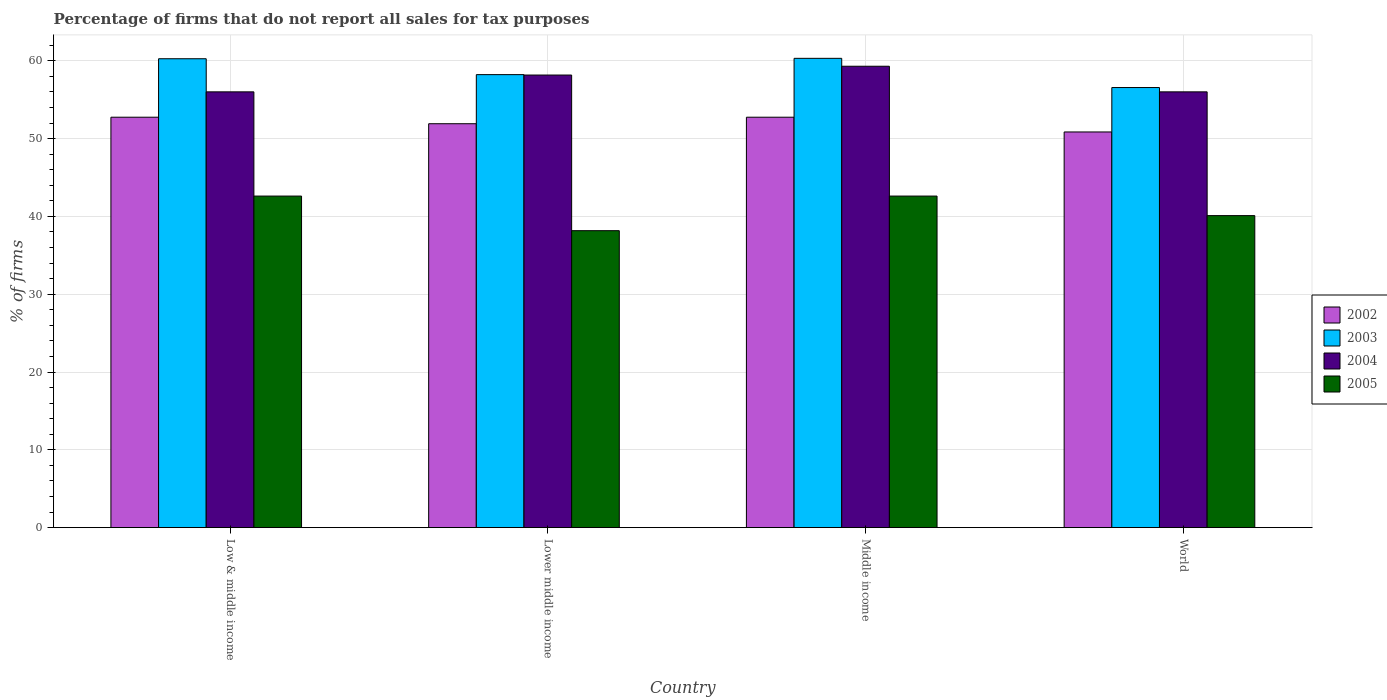How many groups of bars are there?
Provide a succinct answer. 4. Are the number of bars per tick equal to the number of legend labels?
Make the answer very short. Yes. Are the number of bars on each tick of the X-axis equal?
Your answer should be very brief. Yes. How many bars are there on the 2nd tick from the left?
Offer a terse response. 4. How many bars are there on the 4th tick from the right?
Your answer should be very brief. 4. What is the label of the 3rd group of bars from the left?
Your response must be concise. Middle income. What is the percentage of firms that do not report all sales for tax purposes in 2002 in World?
Ensure brevity in your answer.  50.85. Across all countries, what is the maximum percentage of firms that do not report all sales for tax purposes in 2004?
Provide a succinct answer. 59.3. Across all countries, what is the minimum percentage of firms that do not report all sales for tax purposes in 2004?
Offer a very short reply. 56.01. In which country was the percentage of firms that do not report all sales for tax purposes in 2004 minimum?
Your answer should be compact. Low & middle income. What is the total percentage of firms that do not report all sales for tax purposes in 2005 in the graph?
Ensure brevity in your answer.  163.48. What is the difference between the percentage of firms that do not report all sales for tax purposes in 2005 in Low & middle income and that in Lower middle income?
Your response must be concise. 4.45. What is the difference between the percentage of firms that do not report all sales for tax purposes in 2004 in Lower middle income and the percentage of firms that do not report all sales for tax purposes in 2005 in Middle income?
Make the answer very short. 15.55. What is the average percentage of firms that do not report all sales for tax purposes in 2005 per country?
Your response must be concise. 40.87. What is the difference between the percentage of firms that do not report all sales for tax purposes of/in 2002 and percentage of firms that do not report all sales for tax purposes of/in 2005 in World?
Provide a succinct answer. 10.75. What is the ratio of the percentage of firms that do not report all sales for tax purposes in 2002 in Lower middle income to that in Middle income?
Make the answer very short. 0.98. Is the percentage of firms that do not report all sales for tax purposes in 2003 in Low & middle income less than that in Lower middle income?
Offer a terse response. No. Is the difference between the percentage of firms that do not report all sales for tax purposes in 2002 in Lower middle income and Middle income greater than the difference between the percentage of firms that do not report all sales for tax purposes in 2005 in Lower middle income and Middle income?
Ensure brevity in your answer.  Yes. What is the difference between the highest and the second highest percentage of firms that do not report all sales for tax purposes in 2002?
Provide a short and direct response. -0.84. What is the difference between the highest and the lowest percentage of firms that do not report all sales for tax purposes in 2005?
Your answer should be very brief. 4.45. What does the 4th bar from the right in Low & middle income represents?
Make the answer very short. 2002. Is it the case that in every country, the sum of the percentage of firms that do not report all sales for tax purposes in 2002 and percentage of firms that do not report all sales for tax purposes in 2005 is greater than the percentage of firms that do not report all sales for tax purposes in 2004?
Your response must be concise. Yes. How many bars are there?
Give a very brief answer. 16. Are all the bars in the graph horizontal?
Make the answer very short. No. Are the values on the major ticks of Y-axis written in scientific E-notation?
Provide a short and direct response. No. Does the graph contain any zero values?
Offer a terse response. No. Does the graph contain grids?
Make the answer very short. Yes. Where does the legend appear in the graph?
Provide a short and direct response. Center right. How many legend labels are there?
Your answer should be very brief. 4. What is the title of the graph?
Make the answer very short. Percentage of firms that do not report all sales for tax purposes. Does "2005" appear as one of the legend labels in the graph?
Provide a short and direct response. Yes. What is the label or title of the X-axis?
Provide a short and direct response. Country. What is the label or title of the Y-axis?
Give a very brief answer. % of firms. What is the % of firms in 2002 in Low & middle income?
Make the answer very short. 52.75. What is the % of firms of 2003 in Low & middle income?
Keep it short and to the point. 60.26. What is the % of firms in 2004 in Low & middle income?
Give a very brief answer. 56.01. What is the % of firms of 2005 in Low & middle income?
Provide a succinct answer. 42.61. What is the % of firms in 2002 in Lower middle income?
Your answer should be very brief. 51.91. What is the % of firms in 2003 in Lower middle income?
Keep it short and to the point. 58.22. What is the % of firms of 2004 in Lower middle income?
Your answer should be very brief. 58.16. What is the % of firms in 2005 in Lower middle income?
Keep it short and to the point. 38.16. What is the % of firms of 2002 in Middle income?
Provide a short and direct response. 52.75. What is the % of firms in 2003 in Middle income?
Provide a succinct answer. 60.31. What is the % of firms of 2004 in Middle income?
Offer a terse response. 59.3. What is the % of firms in 2005 in Middle income?
Provide a succinct answer. 42.61. What is the % of firms in 2002 in World?
Give a very brief answer. 50.85. What is the % of firms of 2003 in World?
Ensure brevity in your answer.  56.56. What is the % of firms of 2004 in World?
Your answer should be compact. 56.01. What is the % of firms in 2005 in World?
Give a very brief answer. 40.1. Across all countries, what is the maximum % of firms in 2002?
Your answer should be very brief. 52.75. Across all countries, what is the maximum % of firms of 2003?
Give a very brief answer. 60.31. Across all countries, what is the maximum % of firms of 2004?
Keep it short and to the point. 59.3. Across all countries, what is the maximum % of firms of 2005?
Your answer should be compact. 42.61. Across all countries, what is the minimum % of firms of 2002?
Offer a very short reply. 50.85. Across all countries, what is the minimum % of firms of 2003?
Provide a succinct answer. 56.56. Across all countries, what is the minimum % of firms of 2004?
Offer a very short reply. 56.01. Across all countries, what is the minimum % of firms of 2005?
Offer a terse response. 38.16. What is the total % of firms of 2002 in the graph?
Offer a very short reply. 208.25. What is the total % of firms of 2003 in the graph?
Make the answer very short. 235.35. What is the total % of firms in 2004 in the graph?
Provide a succinct answer. 229.47. What is the total % of firms in 2005 in the graph?
Your response must be concise. 163.48. What is the difference between the % of firms in 2002 in Low & middle income and that in Lower middle income?
Offer a terse response. 0.84. What is the difference between the % of firms in 2003 in Low & middle income and that in Lower middle income?
Make the answer very short. 2.04. What is the difference between the % of firms of 2004 in Low & middle income and that in Lower middle income?
Give a very brief answer. -2.16. What is the difference between the % of firms in 2005 in Low & middle income and that in Lower middle income?
Your answer should be very brief. 4.45. What is the difference between the % of firms in 2003 in Low & middle income and that in Middle income?
Your answer should be compact. -0.05. What is the difference between the % of firms of 2004 in Low & middle income and that in Middle income?
Your response must be concise. -3.29. What is the difference between the % of firms of 2002 in Low & middle income and that in World?
Keep it short and to the point. 1.89. What is the difference between the % of firms in 2005 in Low & middle income and that in World?
Your answer should be very brief. 2.51. What is the difference between the % of firms of 2002 in Lower middle income and that in Middle income?
Provide a succinct answer. -0.84. What is the difference between the % of firms of 2003 in Lower middle income and that in Middle income?
Give a very brief answer. -2.09. What is the difference between the % of firms of 2004 in Lower middle income and that in Middle income?
Offer a terse response. -1.13. What is the difference between the % of firms of 2005 in Lower middle income and that in Middle income?
Offer a terse response. -4.45. What is the difference between the % of firms in 2002 in Lower middle income and that in World?
Make the answer very short. 1.06. What is the difference between the % of firms of 2003 in Lower middle income and that in World?
Make the answer very short. 1.66. What is the difference between the % of firms in 2004 in Lower middle income and that in World?
Your answer should be compact. 2.16. What is the difference between the % of firms in 2005 in Lower middle income and that in World?
Provide a short and direct response. -1.94. What is the difference between the % of firms in 2002 in Middle income and that in World?
Make the answer very short. 1.89. What is the difference between the % of firms in 2003 in Middle income and that in World?
Keep it short and to the point. 3.75. What is the difference between the % of firms of 2004 in Middle income and that in World?
Offer a very short reply. 3.29. What is the difference between the % of firms in 2005 in Middle income and that in World?
Keep it short and to the point. 2.51. What is the difference between the % of firms in 2002 in Low & middle income and the % of firms in 2003 in Lower middle income?
Keep it short and to the point. -5.47. What is the difference between the % of firms in 2002 in Low & middle income and the % of firms in 2004 in Lower middle income?
Your answer should be very brief. -5.42. What is the difference between the % of firms of 2002 in Low & middle income and the % of firms of 2005 in Lower middle income?
Offer a terse response. 14.58. What is the difference between the % of firms in 2003 in Low & middle income and the % of firms in 2004 in Lower middle income?
Ensure brevity in your answer.  2.1. What is the difference between the % of firms of 2003 in Low & middle income and the % of firms of 2005 in Lower middle income?
Ensure brevity in your answer.  22.1. What is the difference between the % of firms in 2004 in Low & middle income and the % of firms in 2005 in Lower middle income?
Ensure brevity in your answer.  17.84. What is the difference between the % of firms in 2002 in Low & middle income and the % of firms in 2003 in Middle income?
Make the answer very short. -7.57. What is the difference between the % of firms of 2002 in Low & middle income and the % of firms of 2004 in Middle income?
Provide a short and direct response. -6.55. What is the difference between the % of firms in 2002 in Low & middle income and the % of firms in 2005 in Middle income?
Your response must be concise. 10.13. What is the difference between the % of firms in 2003 in Low & middle income and the % of firms in 2004 in Middle income?
Offer a terse response. 0.96. What is the difference between the % of firms of 2003 in Low & middle income and the % of firms of 2005 in Middle income?
Ensure brevity in your answer.  17.65. What is the difference between the % of firms in 2004 in Low & middle income and the % of firms in 2005 in Middle income?
Offer a terse response. 13.39. What is the difference between the % of firms in 2002 in Low & middle income and the % of firms in 2003 in World?
Your answer should be very brief. -3.81. What is the difference between the % of firms in 2002 in Low & middle income and the % of firms in 2004 in World?
Your answer should be compact. -3.26. What is the difference between the % of firms in 2002 in Low & middle income and the % of firms in 2005 in World?
Offer a terse response. 12.65. What is the difference between the % of firms in 2003 in Low & middle income and the % of firms in 2004 in World?
Your response must be concise. 4.25. What is the difference between the % of firms in 2003 in Low & middle income and the % of firms in 2005 in World?
Your answer should be compact. 20.16. What is the difference between the % of firms of 2004 in Low & middle income and the % of firms of 2005 in World?
Keep it short and to the point. 15.91. What is the difference between the % of firms of 2002 in Lower middle income and the % of firms of 2003 in Middle income?
Offer a terse response. -8.4. What is the difference between the % of firms in 2002 in Lower middle income and the % of firms in 2004 in Middle income?
Provide a short and direct response. -7.39. What is the difference between the % of firms in 2002 in Lower middle income and the % of firms in 2005 in Middle income?
Make the answer very short. 9.3. What is the difference between the % of firms in 2003 in Lower middle income and the % of firms in 2004 in Middle income?
Give a very brief answer. -1.08. What is the difference between the % of firms in 2003 in Lower middle income and the % of firms in 2005 in Middle income?
Provide a succinct answer. 15.61. What is the difference between the % of firms in 2004 in Lower middle income and the % of firms in 2005 in Middle income?
Your answer should be very brief. 15.55. What is the difference between the % of firms of 2002 in Lower middle income and the % of firms of 2003 in World?
Offer a terse response. -4.65. What is the difference between the % of firms in 2002 in Lower middle income and the % of firms in 2004 in World?
Your answer should be compact. -4.1. What is the difference between the % of firms in 2002 in Lower middle income and the % of firms in 2005 in World?
Your answer should be compact. 11.81. What is the difference between the % of firms of 2003 in Lower middle income and the % of firms of 2004 in World?
Offer a very short reply. 2.21. What is the difference between the % of firms of 2003 in Lower middle income and the % of firms of 2005 in World?
Keep it short and to the point. 18.12. What is the difference between the % of firms of 2004 in Lower middle income and the % of firms of 2005 in World?
Keep it short and to the point. 18.07. What is the difference between the % of firms in 2002 in Middle income and the % of firms in 2003 in World?
Your answer should be very brief. -3.81. What is the difference between the % of firms of 2002 in Middle income and the % of firms of 2004 in World?
Offer a very short reply. -3.26. What is the difference between the % of firms in 2002 in Middle income and the % of firms in 2005 in World?
Make the answer very short. 12.65. What is the difference between the % of firms in 2003 in Middle income and the % of firms in 2004 in World?
Offer a terse response. 4.31. What is the difference between the % of firms of 2003 in Middle income and the % of firms of 2005 in World?
Provide a short and direct response. 20.21. What is the difference between the % of firms of 2004 in Middle income and the % of firms of 2005 in World?
Ensure brevity in your answer.  19.2. What is the average % of firms in 2002 per country?
Provide a short and direct response. 52.06. What is the average % of firms in 2003 per country?
Provide a succinct answer. 58.84. What is the average % of firms of 2004 per country?
Provide a succinct answer. 57.37. What is the average % of firms of 2005 per country?
Your answer should be compact. 40.87. What is the difference between the % of firms in 2002 and % of firms in 2003 in Low & middle income?
Make the answer very short. -7.51. What is the difference between the % of firms of 2002 and % of firms of 2004 in Low & middle income?
Provide a short and direct response. -3.26. What is the difference between the % of firms of 2002 and % of firms of 2005 in Low & middle income?
Your response must be concise. 10.13. What is the difference between the % of firms of 2003 and % of firms of 2004 in Low & middle income?
Offer a very short reply. 4.25. What is the difference between the % of firms in 2003 and % of firms in 2005 in Low & middle income?
Provide a short and direct response. 17.65. What is the difference between the % of firms of 2004 and % of firms of 2005 in Low & middle income?
Ensure brevity in your answer.  13.39. What is the difference between the % of firms of 2002 and % of firms of 2003 in Lower middle income?
Offer a terse response. -6.31. What is the difference between the % of firms of 2002 and % of firms of 2004 in Lower middle income?
Offer a very short reply. -6.26. What is the difference between the % of firms of 2002 and % of firms of 2005 in Lower middle income?
Ensure brevity in your answer.  13.75. What is the difference between the % of firms in 2003 and % of firms in 2004 in Lower middle income?
Your answer should be compact. 0.05. What is the difference between the % of firms in 2003 and % of firms in 2005 in Lower middle income?
Offer a terse response. 20.06. What is the difference between the % of firms of 2004 and % of firms of 2005 in Lower middle income?
Give a very brief answer. 20. What is the difference between the % of firms of 2002 and % of firms of 2003 in Middle income?
Give a very brief answer. -7.57. What is the difference between the % of firms in 2002 and % of firms in 2004 in Middle income?
Offer a terse response. -6.55. What is the difference between the % of firms in 2002 and % of firms in 2005 in Middle income?
Ensure brevity in your answer.  10.13. What is the difference between the % of firms of 2003 and % of firms of 2004 in Middle income?
Give a very brief answer. 1.02. What is the difference between the % of firms in 2003 and % of firms in 2005 in Middle income?
Keep it short and to the point. 17.7. What is the difference between the % of firms of 2004 and % of firms of 2005 in Middle income?
Provide a succinct answer. 16.69. What is the difference between the % of firms in 2002 and % of firms in 2003 in World?
Your answer should be very brief. -5.71. What is the difference between the % of firms of 2002 and % of firms of 2004 in World?
Offer a terse response. -5.15. What is the difference between the % of firms of 2002 and % of firms of 2005 in World?
Your answer should be very brief. 10.75. What is the difference between the % of firms in 2003 and % of firms in 2004 in World?
Provide a succinct answer. 0.56. What is the difference between the % of firms in 2003 and % of firms in 2005 in World?
Offer a terse response. 16.46. What is the difference between the % of firms in 2004 and % of firms in 2005 in World?
Your response must be concise. 15.91. What is the ratio of the % of firms of 2002 in Low & middle income to that in Lower middle income?
Your answer should be very brief. 1.02. What is the ratio of the % of firms of 2003 in Low & middle income to that in Lower middle income?
Provide a succinct answer. 1.04. What is the ratio of the % of firms in 2004 in Low & middle income to that in Lower middle income?
Keep it short and to the point. 0.96. What is the ratio of the % of firms in 2005 in Low & middle income to that in Lower middle income?
Offer a very short reply. 1.12. What is the ratio of the % of firms of 2002 in Low & middle income to that in Middle income?
Your answer should be compact. 1. What is the ratio of the % of firms of 2003 in Low & middle income to that in Middle income?
Give a very brief answer. 1. What is the ratio of the % of firms in 2004 in Low & middle income to that in Middle income?
Provide a short and direct response. 0.94. What is the ratio of the % of firms in 2005 in Low & middle income to that in Middle income?
Your response must be concise. 1. What is the ratio of the % of firms in 2002 in Low & middle income to that in World?
Offer a terse response. 1.04. What is the ratio of the % of firms in 2003 in Low & middle income to that in World?
Provide a short and direct response. 1.07. What is the ratio of the % of firms in 2004 in Low & middle income to that in World?
Make the answer very short. 1. What is the ratio of the % of firms in 2005 in Low & middle income to that in World?
Offer a very short reply. 1.06. What is the ratio of the % of firms in 2002 in Lower middle income to that in Middle income?
Your answer should be compact. 0.98. What is the ratio of the % of firms in 2003 in Lower middle income to that in Middle income?
Offer a very short reply. 0.97. What is the ratio of the % of firms in 2004 in Lower middle income to that in Middle income?
Your response must be concise. 0.98. What is the ratio of the % of firms of 2005 in Lower middle income to that in Middle income?
Your response must be concise. 0.9. What is the ratio of the % of firms in 2002 in Lower middle income to that in World?
Keep it short and to the point. 1.02. What is the ratio of the % of firms of 2003 in Lower middle income to that in World?
Offer a terse response. 1.03. What is the ratio of the % of firms of 2004 in Lower middle income to that in World?
Your answer should be very brief. 1.04. What is the ratio of the % of firms of 2005 in Lower middle income to that in World?
Offer a very short reply. 0.95. What is the ratio of the % of firms in 2002 in Middle income to that in World?
Offer a terse response. 1.04. What is the ratio of the % of firms of 2003 in Middle income to that in World?
Make the answer very short. 1.07. What is the ratio of the % of firms in 2004 in Middle income to that in World?
Your response must be concise. 1.06. What is the ratio of the % of firms in 2005 in Middle income to that in World?
Offer a terse response. 1.06. What is the difference between the highest and the second highest % of firms of 2002?
Give a very brief answer. 0. What is the difference between the highest and the second highest % of firms of 2003?
Your response must be concise. 0.05. What is the difference between the highest and the second highest % of firms in 2004?
Your answer should be compact. 1.13. What is the difference between the highest and the second highest % of firms of 2005?
Your answer should be compact. 0. What is the difference between the highest and the lowest % of firms of 2002?
Offer a terse response. 1.89. What is the difference between the highest and the lowest % of firms of 2003?
Offer a terse response. 3.75. What is the difference between the highest and the lowest % of firms of 2004?
Provide a succinct answer. 3.29. What is the difference between the highest and the lowest % of firms of 2005?
Give a very brief answer. 4.45. 